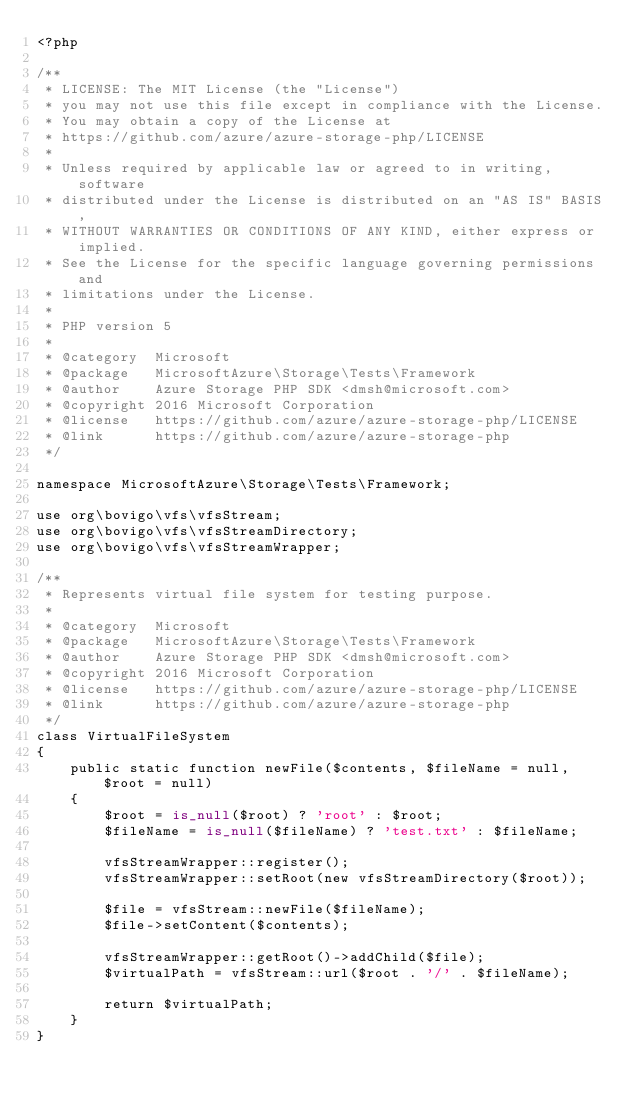Convert code to text. <code><loc_0><loc_0><loc_500><loc_500><_PHP_><?php

/**
 * LICENSE: The MIT License (the "License")
 * you may not use this file except in compliance with the License.
 * You may obtain a copy of the License at
 * https://github.com/azure/azure-storage-php/LICENSE
 *
 * Unless required by applicable law or agreed to in writing, software
 * distributed under the License is distributed on an "AS IS" BASIS,
 * WITHOUT WARRANTIES OR CONDITIONS OF ANY KIND, either express or implied.
 * See the License for the specific language governing permissions and
 * limitations under the License.
 *
 * PHP version 5
 *
 * @category  Microsoft
 * @package   MicrosoftAzure\Storage\Tests\Framework
 * @author    Azure Storage PHP SDK <dmsh@microsoft.com>
 * @copyright 2016 Microsoft Corporation
 * @license   https://github.com/azure/azure-storage-php/LICENSE
 * @link      https://github.com/azure/azure-storage-php
 */
 
namespace MicrosoftAzure\Storage\Tests\Framework;

use org\bovigo\vfs\vfsStream;
use org\bovigo\vfs\vfsStreamDirectory;
use org\bovigo\vfs\vfsStreamWrapper;

/**
 * Represents virtual file system for testing purpose.
 *
 * @category  Microsoft
 * @package   MicrosoftAzure\Storage\Tests\Framework
 * @author    Azure Storage PHP SDK <dmsh@microsoft.com>
 * @copyright 2016 Microsoft Corporation
 * @license   https://github.com/azure/azure-storage-php/LICENSE
 * @link      https://github.com/azure/azure-storage-php
 */
class VirtualFileSystem
{
    public static function newFile($contents, $fileName = null, $root = null)
    {
        $root = is_null($root) ? 'root' : $root;
        $fileName = is_null($fileName) ? 'test.txt' : $fileName;

        vfsStreamWrapper::register();
        vfsStreamWrapper::setRoot(new vfsStreamDirectory($root));
        
        $file = vfsStream::newFile($fileName);
        $file->setContent($contents);
        
        vfsStreamWrapper::getRoot()->addChild($file);
        $virtualPath = vfsStream::url($root . '/' . $fileName);
        
        return $virtualPath;
    }
}
</code> 